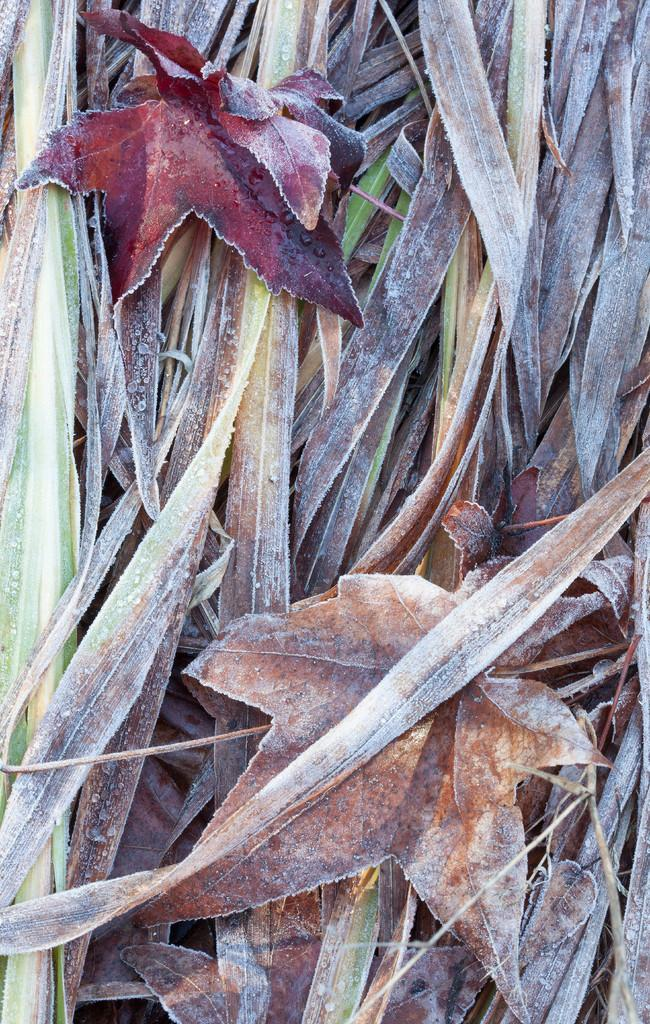What type of vegetation can be seen in the image? There are leaves in the image. How many cakes are being prepared by the bee in the image? There is no bee or cakes present in the image; it only features leaves. 